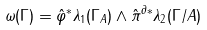<formula> <loc_0><loc_0><loc_500><loc_500>\omega ( \Gamma ) = \hat { \varphi } ^ { * } \lambda _ { 1 } ( \Gamma _ { A } ) \wedge \hat { \pi } ^ { \partial * } \lambda _ { 2 } ( \Gamma / A )</formula> 